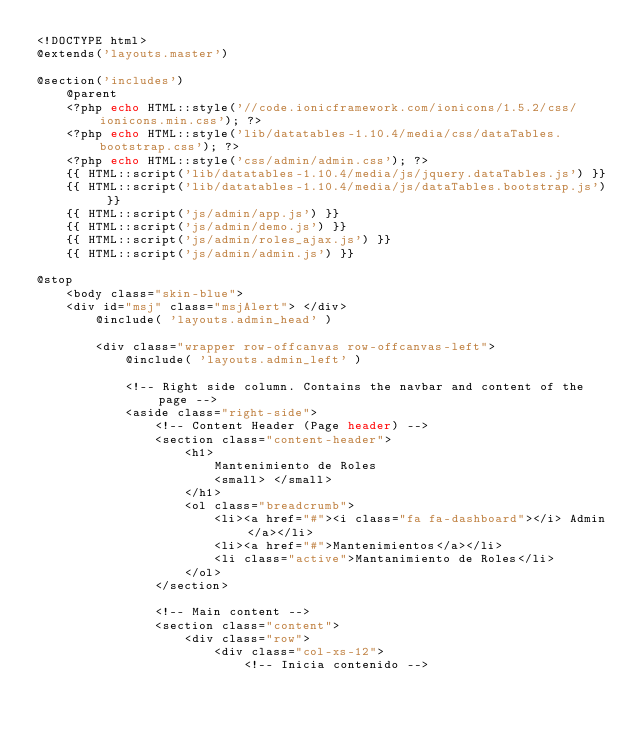<code> <loc_0><loc_0><loc_500><loc_500><_PHP_><!DOCTYPE html>
@extends('layouts.master')  

@section('includes')
    @parent
    <?php echo HTML::style('//code.ionicframework.com/ionicons/1.5.2/css/ionicons.min.css'); ?>
    <?php echo HTML::style('lib/datatables-1.10.4/media/css/dataTables.bootstrap.css'); ?>
    <?php echo HTML::style('css/admin/admin.css'); ?>
    {{ HTML::script('lib/datatables-1.10.4/media/js/jquery.dataTables.js') }}
    {{ HTML::script('lib/datatables-1.10.4/media/js/dataTables.bootstrap.js') }}
    {{ HTML::script('js/admin/app.js') }}
    {{ HTML::script('js/admin/demo.js') }}
    {{ HTML::script('js/admin/roles_ajax.js') }}
    {{ HTML::script('js/admin/admin.js') }}

@stop
    <body class="skin-blue">
    <div id="msj" class="msjAlert"> </div>
        @include( 'layouts.admin_head' )

        <div class="wrapper row-offcanvas row-offcanvas-left">
            @include( 'layouts.admin_left' )

            <!-- Right side column. Contains the navbar and content of the page -->
            <aside class="right-side">
                <!-- Content Header (Page header) -->
                <section class="content-header">
                    <h1>
                        Mantenimiento de Roles
                        <small> </small>
                    </h1>
                    <ol class="breadcrumb">
                        <li><a href="#"><i class="fa fa-dashboard"></i> Admin</a></li>
                        <li><a href="#">Mantenimientos</a></li>
                        <li class="active">Mantanimiento de Roles</li>
                    </ol>
                </section>

                <!-- Main content -->
                <section class="content">
                    <div class="row">
                        <div class="col-xs-12">                
                            <!-- Inicia contenido --></code> 